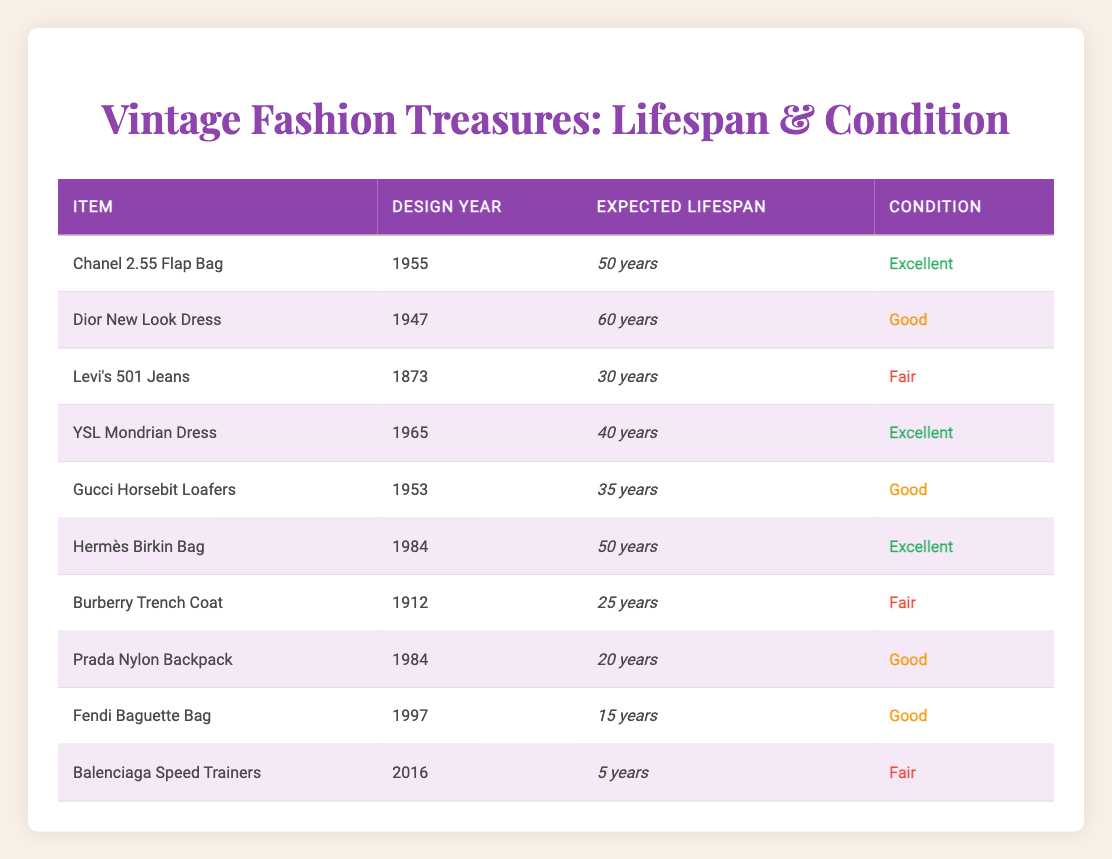What is the expected lifespan of the Dior New Look Dress? According to the table, the Dior New Look Dress has an expected lifespan of 60 years.
Answer: 60 years Which item has the longest expected lifespan? The item with the longest expected lifespan is the Dior New Look Dress, which is 60 years.
Answer: Dior New Look Dress How many items have an expected lifespan of 50 years? There are two items listed with an expected lifespan of 50 years: the Chanel 2.55 Flap Bag and the Hermès Birkin Bag.
Answer: 2 Is the condition of the Burberry Trench Coat excellent? No, the condition of the Burberry Trench Coat is listed as fair, not excellent.
Answer: No What is the average expected lifespan of items in excellent condition? To find the average, we sum the expected lifespans of the excellent condition items: 50 (Chanel 2.55 Flap Bag) + 60 (Dior New Look Dress) + 40 (YSL Mondrian Dress) + 50 (Hermès Birkin Bag) = 200 years. There are 4 items, so the average is 200/4 = 50 years.
Answer: 50 years How many items are older than 40 years? Items older than 40 years include Chanel 2.55 Flap Bag (1955), Dior New Look Dress (1947), Levi's 501 Jeans (1873), YSL Mondrian Dress (1965), and Gucci Horsebit Loafers (1953). These total five items.
Answer: 5 Which item has the shortest expected lifespan? The item with the shortest expected lifespan is the Balenciaga Speed Trainers with 5 years.
Answer: Balenciaga Speed Trainers Is it true that all items listed have an expected lifespan of more than 10 years? No, it is not true as the Fendi Baguette Bag has an expected lifespan of only 15 years and the Balenciaga Speed Trainers have an expected lifespan of just 5 years.
Answer: No 